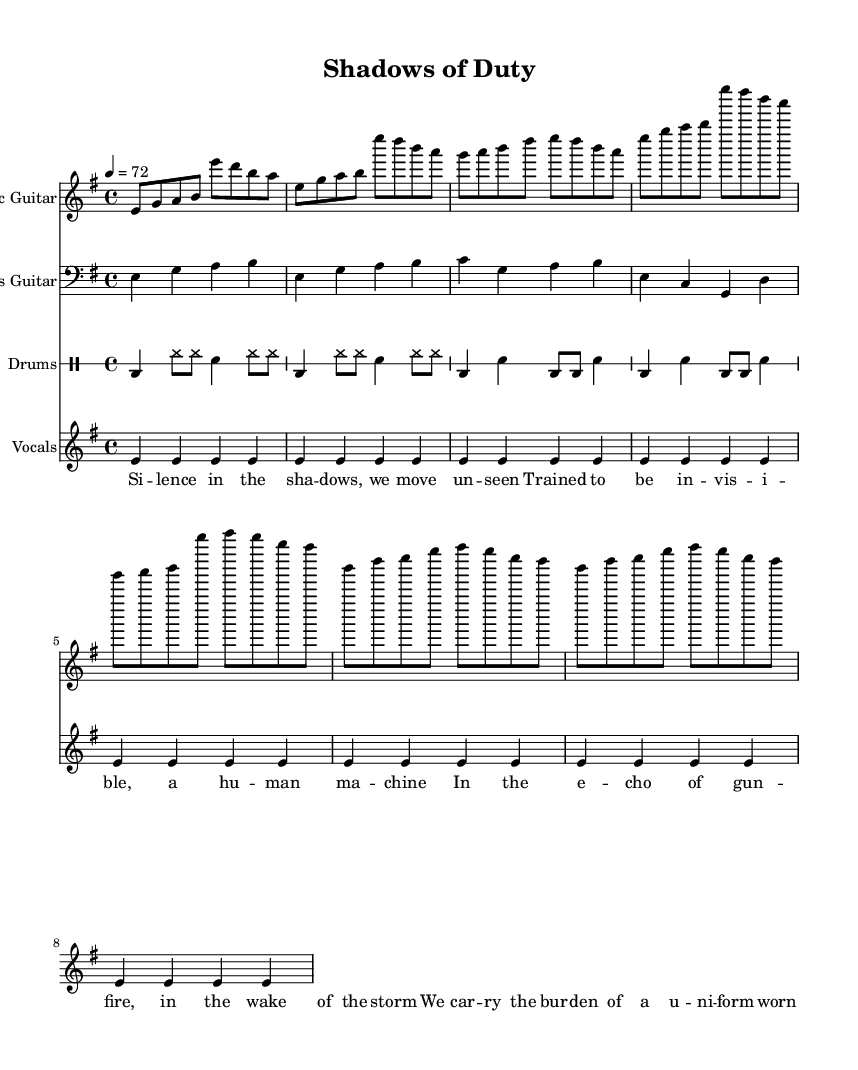What is the key signature of this music? The key signature is indicated at the beginning of the sheet music. It shows that there are no sharps or flats, which corresponds to E minor.
Answer: E minor What is the time signature of this music? The time signature is placed at the beginning of the piece, showing that each measure contains four beats, which means it is in 4/4 time.
Answer: 4/4 What is the tempo marking for this music? The tempo marking is presented in the score, indicating a speed of 72 beats per minute, which is indicated with the tempo instruction "4 = 72".
Answer: 72 What is the first instrument listed in the score? The instruments are introduced by their names in the score. The first one listed is the Electric Guitar, indicating that it plays the primary melody.
Answer: Electric Guitar How many measures are there in the verse section? By reviewing the verse section in the score, we can count the measures directly; there are four measures in total for the verse.
Answer: 4 What is the predominant theme of the lyrics? The lyrics reflect an introspective theme regarding the psychological impact of combat and covert operations. Words like "silence," "invisible," and "burden" capture the depth of the theme.
Answer: Psychological impact What kind of drum pattern is primarily used in the verse? The drum patterns can be analyzed in the score. The verse primarily consists of a kick drum on the downbeat and hi-hat accents on the offbeats, suggesting a steady and driving rhythm.
Answer: Steady driving rhythm 